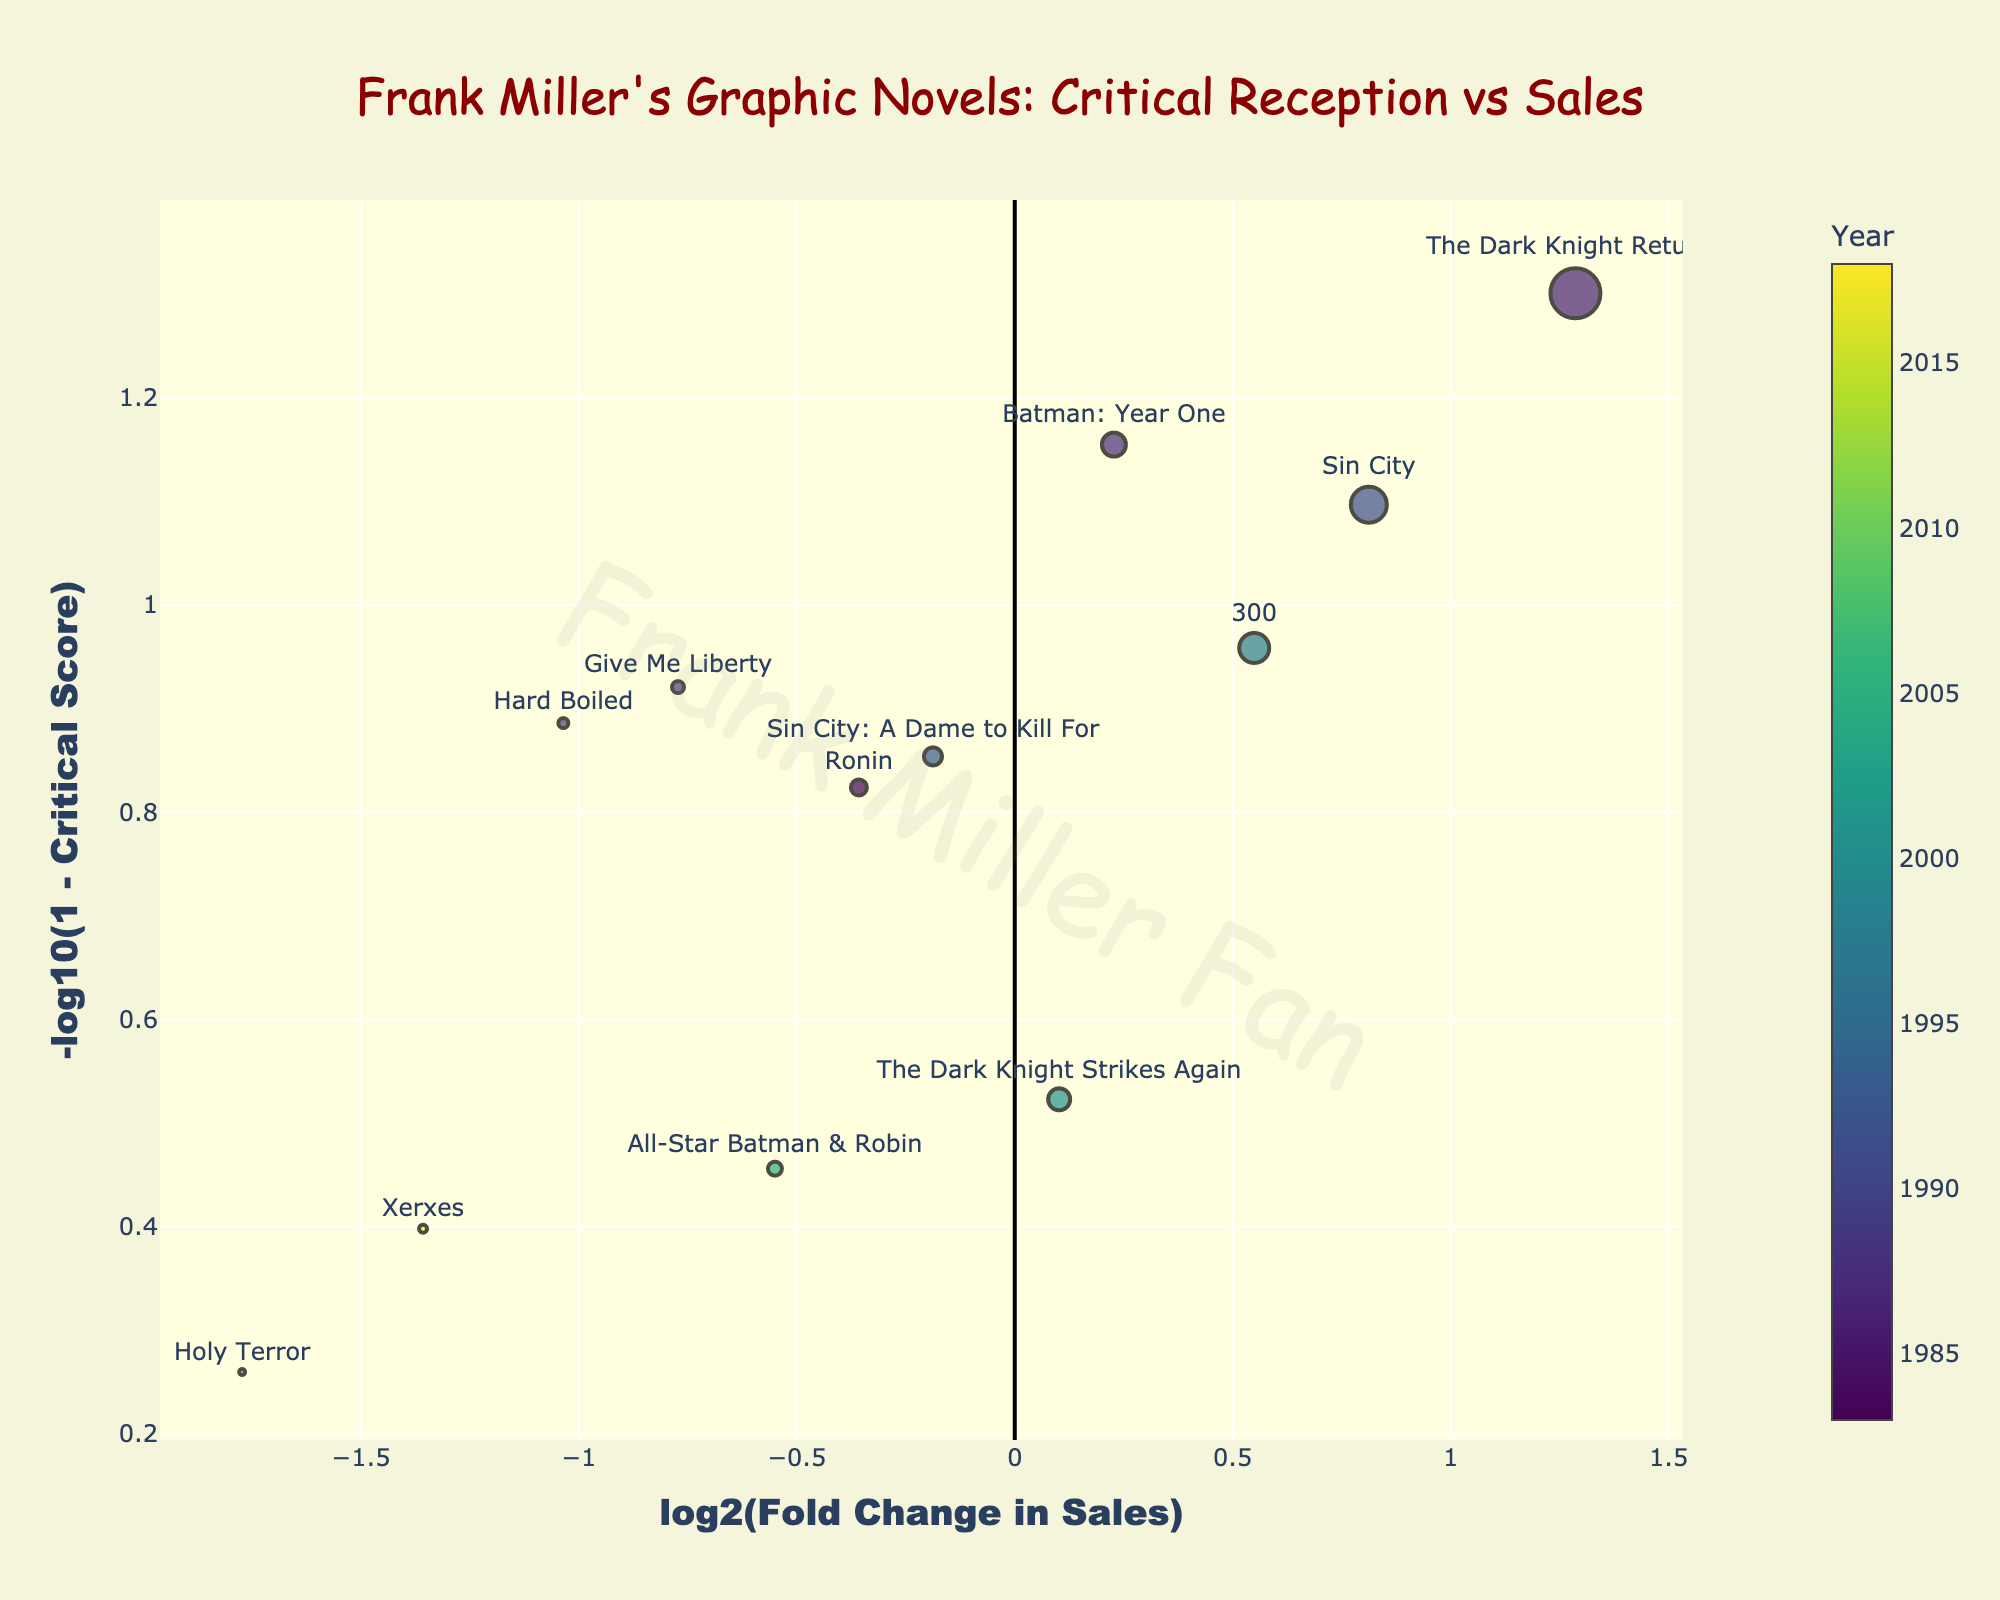What is the title of the plot? The title is located at the top center of the plot, which reads "Frank Miller's Graphic Novels: Critical Reception vs Sales".
Answer: Frank Miller's Graphic Novels: Critical Reception vs Sales What do the colors of the markers represent? The color of each marker represents the year the graphic novel was published. This is indicated by the color scale on the right side of the plot titled "Year".
Answer: Year of publication Which axis represents the log2 fold change in sales? The x-axis represents the log2 fold change in sales. This is indicated by the label "log2(Fold Change in Sales)" below the x-axis.
Answer: x-axis How many graphic novels are plotted in the figure? By counting the total number of markers (each corresponding to a graphic novel) present in the plot, we find there are twelve graphic novels plotted.
Answer: 12 Which graphic novel has the highest critical score? Identifying the novel with the highest -log10(1 - Critical Score) value, we find that "The Dark Knight Returns" is located at the highest y-axis position.
Answer: The Dark Knight Returns Which novel has the lowest sales figure? By noting the smallest marker size on the plot and checking the hover text, it shows that "Holy Terror" has the lowest sales figure (0.3 million).
Answer: Holy Terror What's the overall trend in sales figures versus critical reception for Frank Miller's graphic novels? Observing the spread of the markers, there doesn't seem to be a strong correlation; however, higher critical scores generally seem associated with higher sales, with a few exceptions.
Answer: Generally, higher critical scores have higher sales Which novels did Frank Miller release in the 1980s, and how did they perform in terms of sales and critical reception? Searching for novels from the 1980s by looking at colors from the earlier part of the colorscale and referencing the hover text, "The Dark Knight Returns" (1986), "Batman: Year One" (1987), and "Ronin" (1983) are released in the 1980s. These had higher critical scores (85-95) and relatively high sales.
Answer: The Dark Knight Returns, Batman: Year One, Ronin; high critical reception and sales Which novels have a negative log2 fold change in sales compared to the average sales figure? By checking markers to the left of the zero on the x-axis, and verifying the hover text, novels such as "Ronin", "Give Me Liberty", "Hard Boiled", "Holy Terror", and "Xerxes" have lower than average sales figures.
Answer: Ronin, Give Me Liberty, Hard Boiled, Holy Terror, Xerxes 